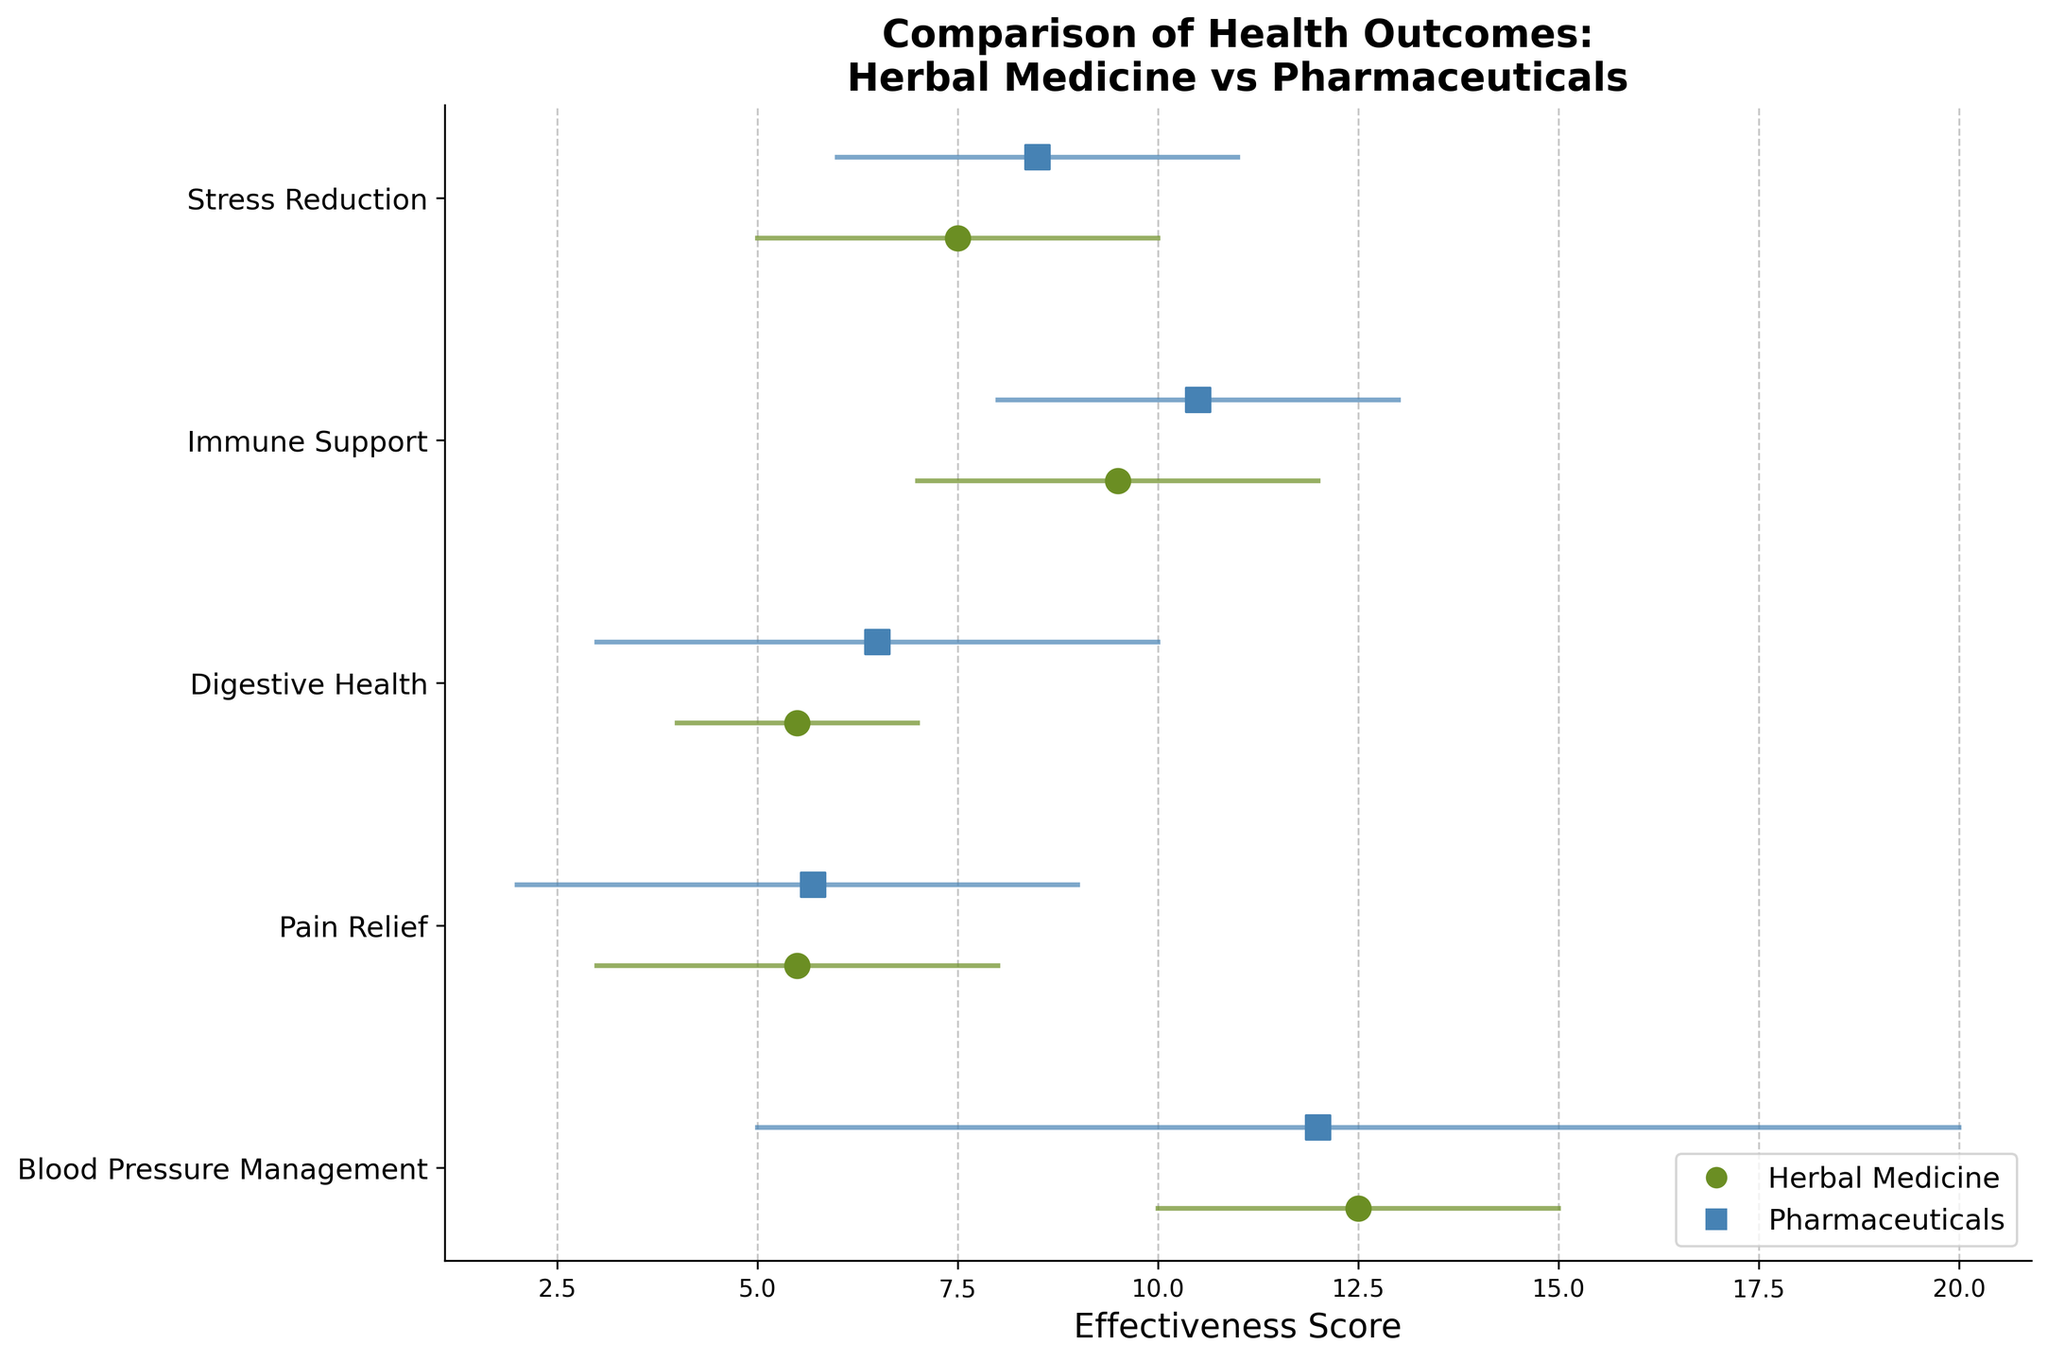What's the title of the figure? The title of a figure is generally located at the top and is meant to describe what the figure represents. Here, the title clearly states the purpose of the figure.
Answer: Comparison of Health Outcomes: Herbal Medicine vs Pharmaceuticals How many health outcome categories are compared in the figure? To find the number of health outcome categories compared, count the distinct labels on the y-axis of the figure. Each label represents a different category.
Answer: Five What are the minimum and maximum effectiveness scores for immune support using pharmaceuticals? To find these scores, look at the range of the horizontal line and endpoints for the 'Immune Support' category plotted with a "square" marker (representing pharmaceuticals).
Answer: Min: 8, Max: 13 Which method has a higher mean score for digestive health? Identify the positions of the markers for digestive health. Compare the circle (herbal medicine) and square (pharmaceuticals) markers' horizontal positions. The one further right has a higher mean score.
Answer: Pharmaceuticals In which category is the effectiveness range the smallest for herbal medicine? Evaluate the length of the horizontal lines representing the range of effectiveness scores for each category with circles (herbal medicine). The shortest line indicates the smallest range.
Answer: Digestive Health How does the mean effectiveness score for stress reduction compare between the two methods? Compare the horizontal positions of the markers (circle and square) for stress reduction. The difference between their positions shows how their mean scores compare.
Answer: Pharmaceuticals is higher by 1 point Which category shows the largest difference in mean effectiveness scores between the two methods? For each category, determine the horizontal distance between the circle and square markers. Identify the category with the greatest gap.
Answer: Digestive Health, by 1 point What is the mean effectiveness score for blood pressure management using herbal medicine? Look for the position of the circle marker in the 'Blood Pressure Management' category. The number on the x-axis at this position gives the mean score.
Answer: 12.5 Which method appears more consistent (narrower range) for pain relief? Compare the lengths of the lines representing the range of effectiveness scores for pain relief in both methods. The shorter line indicates more consistency.
Answer: Herbal Medicine What is the mean effectiveness score for immune support using herbal medicine? Locate the circle marker's position for the 'Immune Support' category on the x-axis to find its corresponding mean score.
Answer: 9.5 